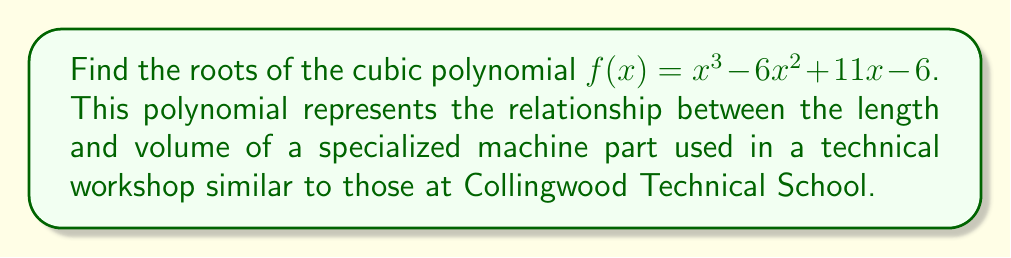Teach me how to tackle this problem. To find the roots of this cubic polynomial, we'll use factoring techniques:

1) First, let's check if there's a rational root. We can use the rational root theorem, which states that if a polynomial equation has integer coefficients, then any rational solution, when reduced to lowest terms, will have a numerator that divides the constant term and a denominator that divides the leading coefficient.

   Possible rational roots: $\pm 1, \pm 2, \pm 3, \pm 6$

2) Let's try $x = 1$:
   $f(1) = 1^3 - 6(1)^2 + 11(1) - 6 = 1 - 6 + 11 - 6 = 0$

   So, $(x - 1)$ is a factor of $f(x)$.

3) We can now use polynomial long division to divide $f(x)$ by $(x - 1)$:

   $f(x) = (x - 1)(x^2 - 5x + 6)$

4) Now we need to factor the quadratic term $x^2 - 5x + 6$:
   
   This can be factored as $(x - 2)(x - 3)$

5) Therefore, the complete factorization is:

   $f(x) = (x - 1)(x - 2)(x - 3)$

6) The roots of the polynomial are the values that make each factor equal to zero:

   $x - 1 = 0$, $x = 1$
   $x - 2 = 0$, $x = 2$
   $x - 3 = 0$, $x = 3$
Answer: $x = 1, 2, 3$ 